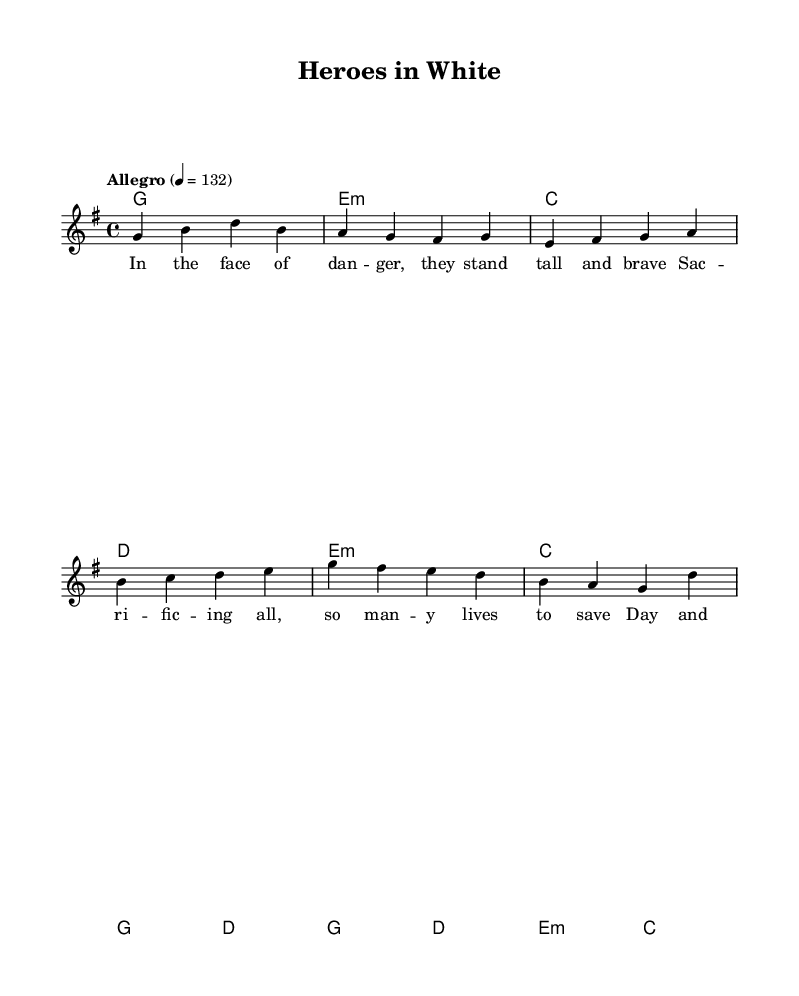What is the key signature of this music? The key signature is indicated by the placement of sharps and flats after the clef. In this case, there is one sharp (F#), which signifies the key of G major.
Answer: G major What is the time signature of this music? The time signature appears immediately after the key signature on the staff. It is a 4/4 time signature, meaning there are four beats in a measure and the quarter note gets one beat.
Answer: 4/4 What is the tempo marking provided in this music? The tempo marking can be found below the time signature and indicates the speed of the piece. Here, it is marked "Allegro," which means to play at a fast, lively pace.
Answer: Allegro How many measures are in the melody section for the verse? To count the measures in the verse, look at the melody and count each bar separated by vertical lines. The verse has four measures.
Answer: 4 What is the main theme of the lyrics in the chorus? The chorus lyrics express the admiration for healthcare workers, emphasizing their brightness and guidance during difficult times. This can be extracted by reading through the lyrics in the chorus section.
Answer: Heroes in white What is the relation between the verse and pre-chorus in terms of musical structure? The verse and pre-chorus are structurally linked as the verse sets the scene of bravery, followed by a pre-chorus that builds up the emotion leading into the chorus, creating a narrative flow in the song's story.
Answer: Narrative flow How do the harmonies change from the verse to the chorus? By examining the chord progression, the harmonies shift from G major in the verse to a combination of G major, D major, E minor, and C major in the chorus, indicating an elevation in emotional intensity and musical complexity.
Answer: Shift in harmony 